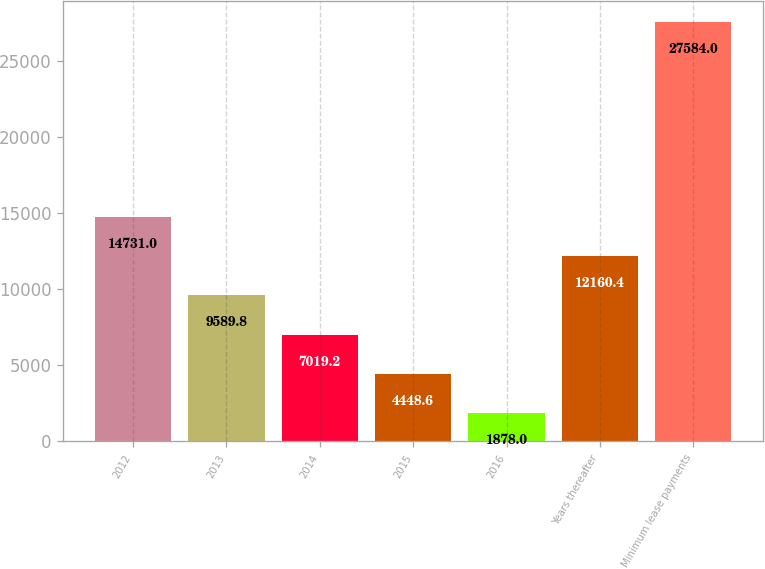<chart> <loc_0><loc_0><loc_500><loc_500><bar_chart><fcel>2012<fcel>2013<fcel>2014<fcel>2015<fcel>2016<fcel>Years thereafter<fcel>Minimum lease payments<nl><fcel>14731<fcel>9589.8<fcel>7019.2<fcel>4448.6<fcel>1878<fcel>12160.4<fcel>27584<nl></chart> 